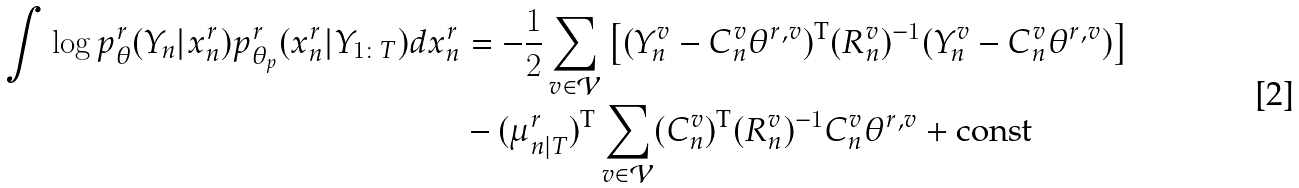<formula> <loc_0><loc_0><loc_500><loc_500>\int \log p _ { \theta } ^ { r } ( Y _ { n } | x _ { n } ^ { r } ) p _ { \theta _ { p } } ^ { r } ( x _ { n } ^ { r } | Y _ { 1 \colon T } ) d x _ { n } ^ { r } & = - \frac { 1 } { 2 } \sum _ { v \in \mathcal { V } } \left [ ( Y _ { n } ^ { v } - C _ { n } ^ { v } \theta ^ { r , v } ) ^ { \text {T} } ( R _ { n } ^ { v } ) ^ { - 1 } ( Y _ { n } ^ { v } - C _ { n } ^ { v } \theta ^ { r , v } ) \right ] \\ & - ( \mu _ { n | T } ^ { r } ) ^ { \text {T} } \sum _ { v \in \mathcal { V } } ( C _ { n } ^ { v } ) ^ { \text {T} } ( R _ { n } ^ { v } ) ^ { - 1 } C _ { n } ^ { v } \theta ^ { r , v } + \text {const}</formula> 